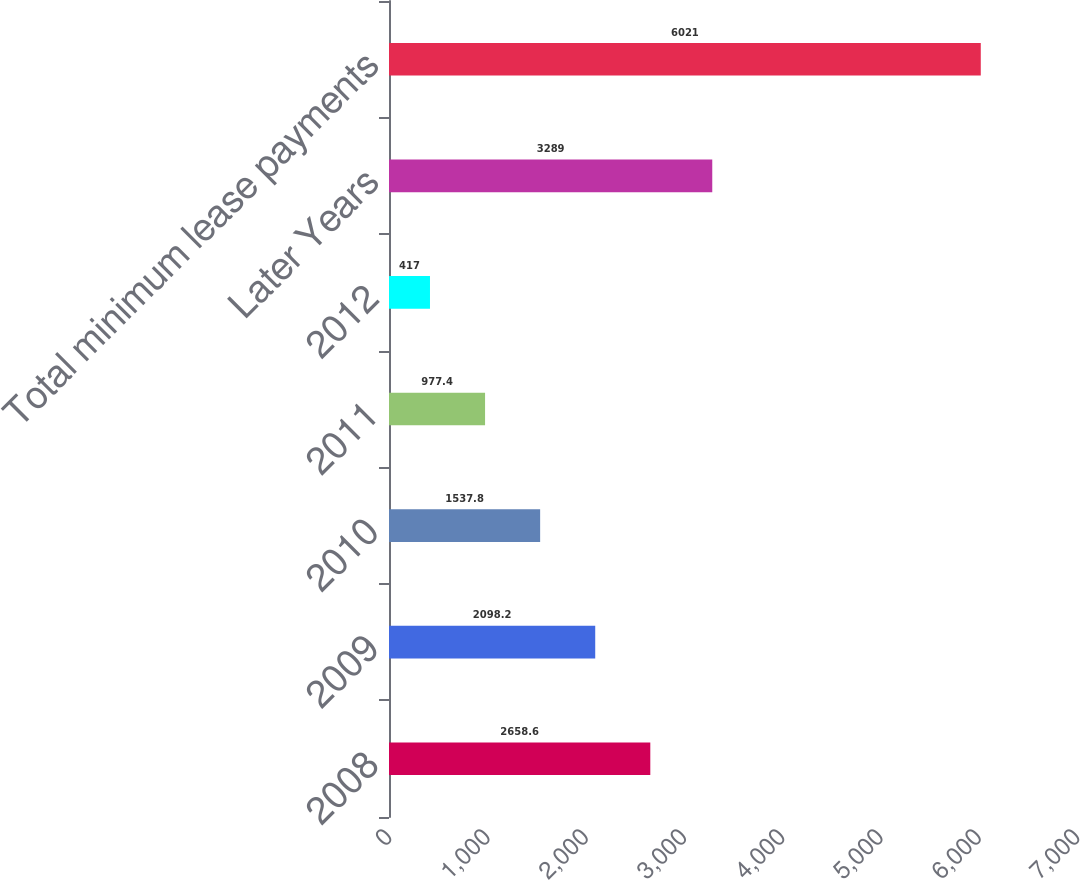<chart> <loc_0><loc_0><loc_500><loc_500><bar_chart><fcel>2008<fcel>2009<fcel>2010<fcel>2011<fcel>2012<fcel>Later Years<fcel>Total minimum lease payments<nl><fcel>2658.6<fcel>2098.2<fcel>1537.8<fcel>977.4<fcel>417<fcel>3289<fcel>6021<nl></chart> 